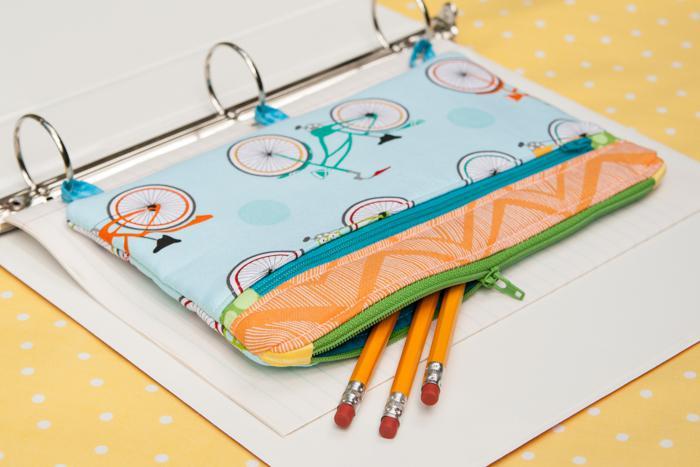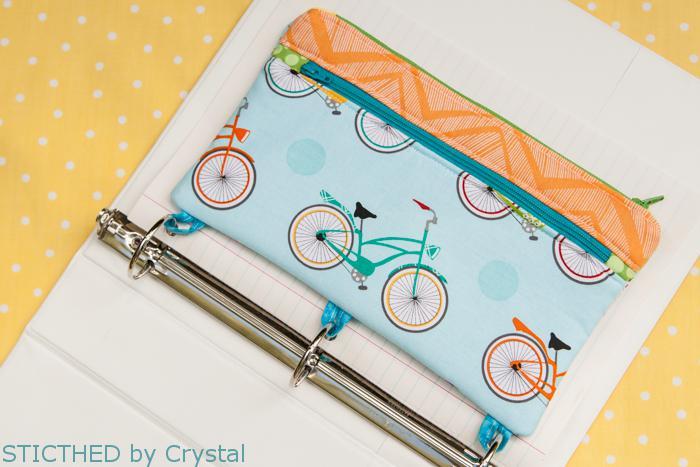The first image is the image on the left, the second image is the image on the right. Considering the images on both sides, is "At least one pencil case has a brown bear on it." valid? Answer yes or no. No. The first image is the image on the left, the second image is the image on the right. Given the left and right images, does the statement "At least one of the pencil cases has a brown cartoon bear on it." hold true? Answer yes or no. No. 